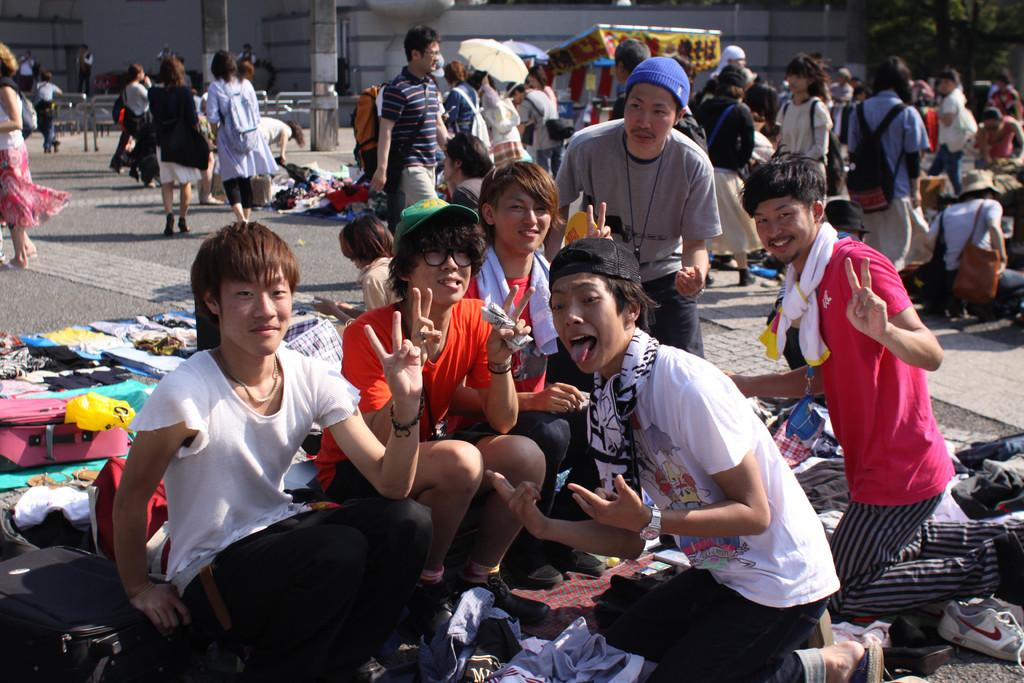How many people are in the image? There is a group of people in the image, but the exact number is not specified. Can you describe the arrangement of the people in the image? The people are scattered throughout the image. What type of items can be seen in the image besides people? There are cloth items and suitcases in the image. What can be seen in the background of the image? There is a building in the background of the image. What type of news is being reported by the plate in the image? There is no plate present in the image, and therefore no news can be reported by it. 